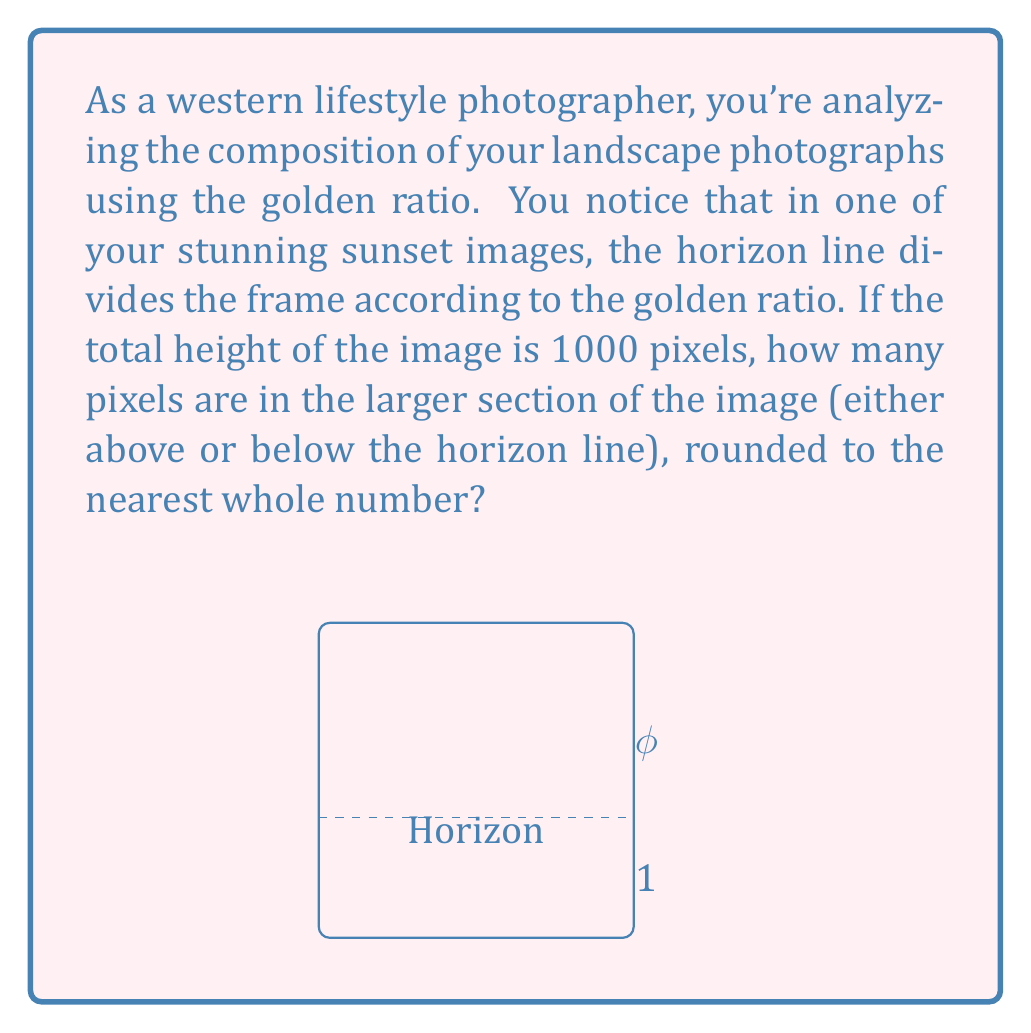Can you solve this math problem? Let's approach this step-by-step:

1) The golden ratio, denoted by φ (phi), is approximately equal to 1.618033988749895.

2) In a composition following the golden ratio, the ratio of the larger part to the smaller part is equal to φ.

3) Let's denote the height of the larger section as x. Then, the height of the smaller section will be (1000 - x).

4) According to the golden ratio principle:

   $$\frac{x}{1000-x} = φ$$

5) We can write this as an equation:

   $$x = φ(1000-x)$$

6) Expanding the right side:

   $$x = 1000φ - φx$$

7) Adding φx to both sides:

   $$x + φx = 1000φ$$

8) Factoring out x:

   $$x(1 + φ) = 1000φ$$

9) Dividing both sides by (1 + φ):

   $$x = \frac{1000φ}{1 + φ}$$

10) Now, let's substitute the value of φ:

    $$x = \frac{1000 * 1.618033988749895}{1 + 1.618033988749895} = 618.0339887498948$$

11) Rounding to the nearest whole number:

    x ≈ 618 pixels

Therefore, the larger section of the image is approximately 618 pixels tall.
Answer: 618 pixels 